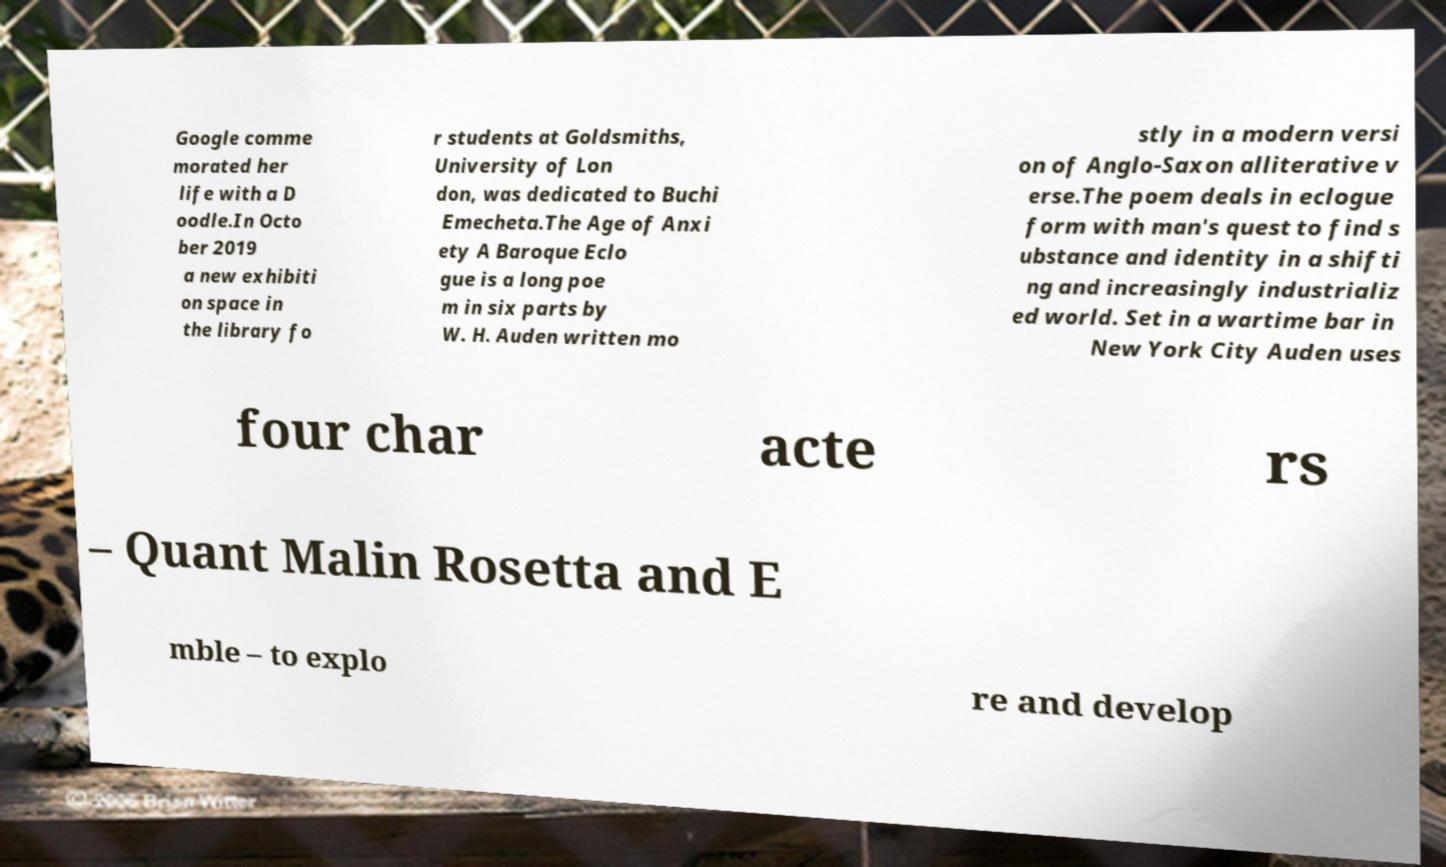There's text embedded in this image that I need extracted. Can you transcribe it verbatim? Google comme morated her life with a D oodle.In Octo ber 2019 a new exhibiti on space in the library fo r students at Goldsmiths, University of Lon don, was dedicated to Buchi Emecheta.The Age of Anxi ety A Baroque Eclo gue is a long poe m in six parts by W. H. Auden written mo stly in a modern versi on of Anglo-Saxon alliterative v erse.The poem deals in eclogue form with man's quest to find s ubstance and identity in a shifti ng and increasingly industrializ ed world. Set in a wartime bar in New York City Auden uses four char acte rs – Quant Malin Rosetta and E mble – to explo re and develop 